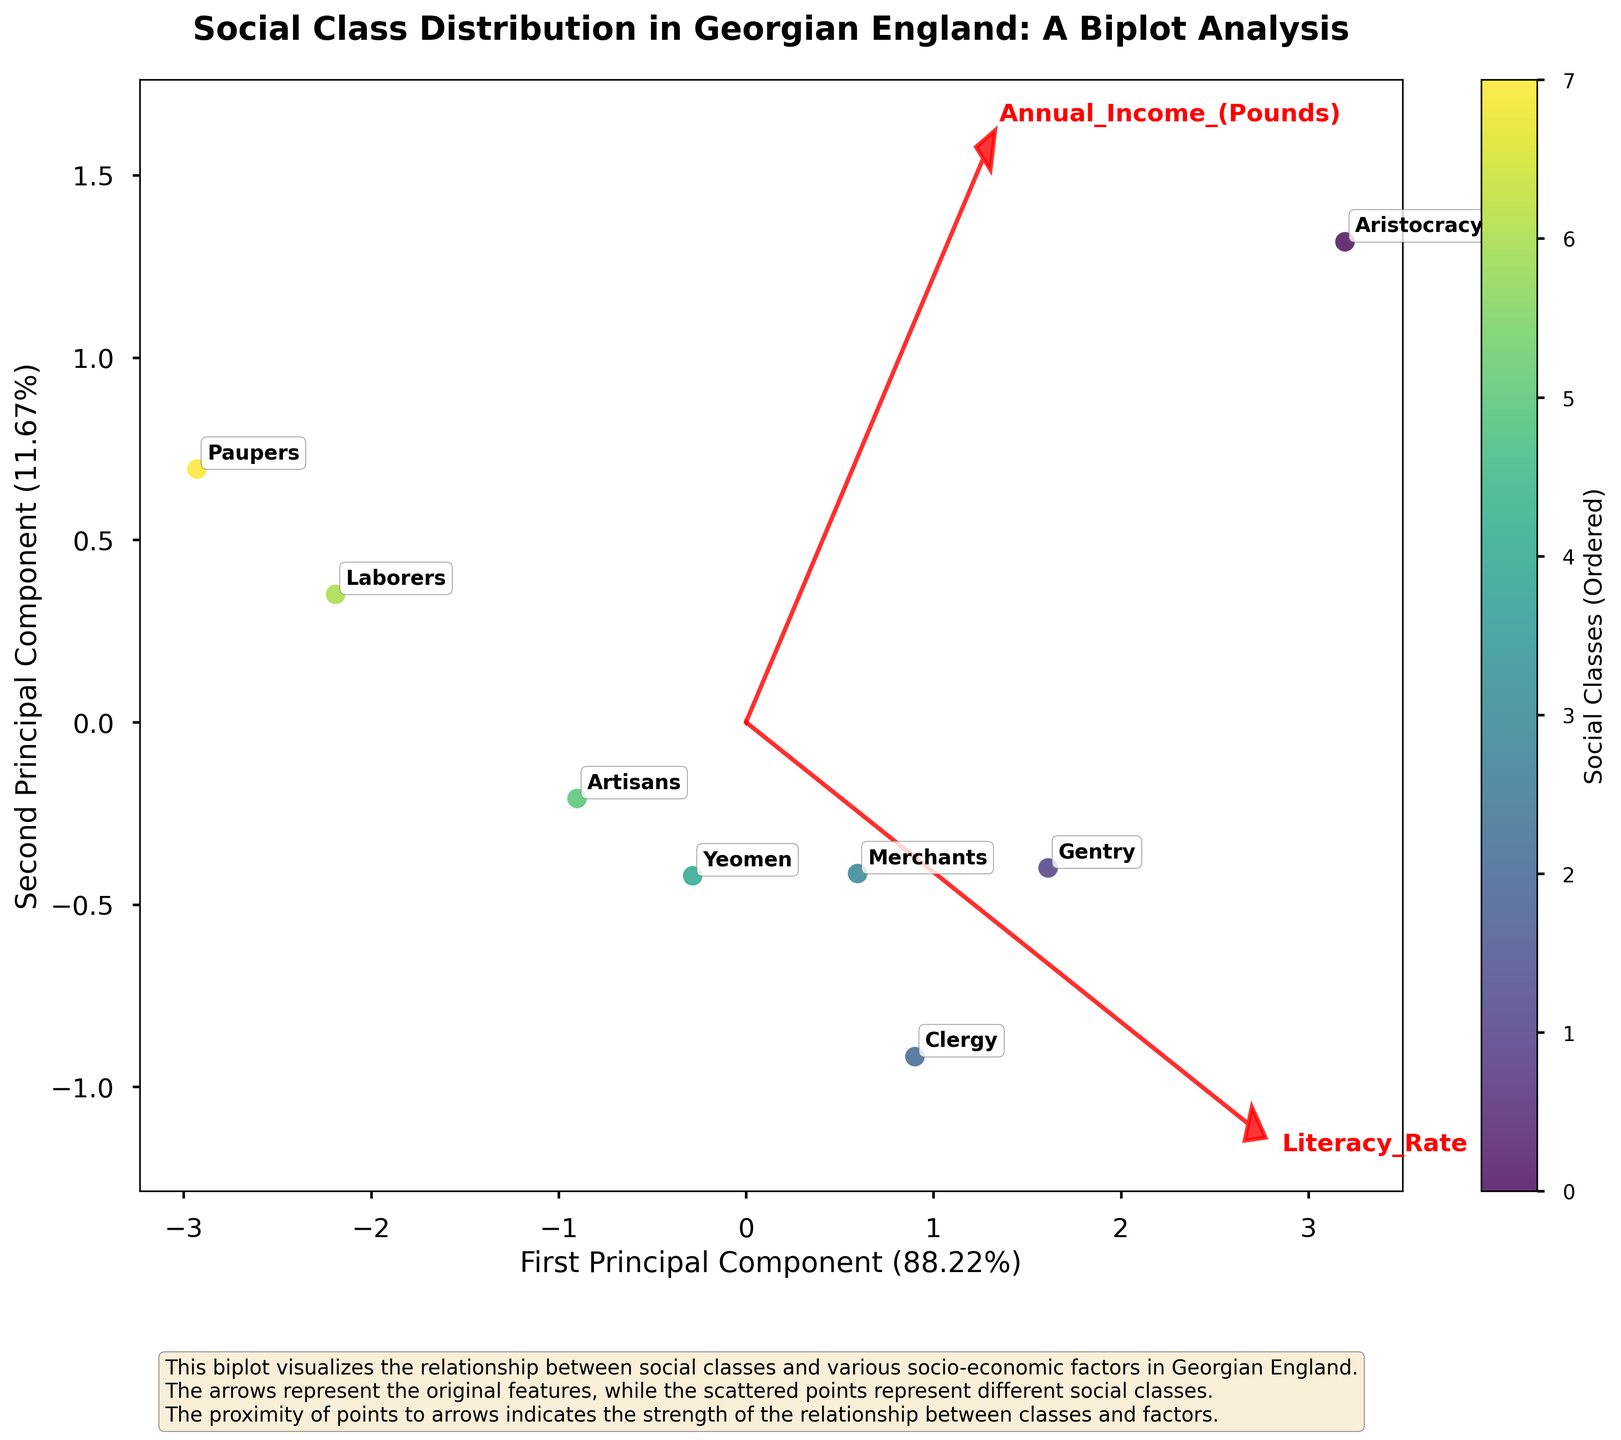What is the title of the biplot? The title is located at the top of the figure. It summarizes the content and context of the plot. The title reads "Social Class Distribution in Georgian England: A Biplot Analysis"
Answer: Social Class Distribution in Georgian England: A Biplot Analysis Which social class has the highest political influence? Political influence is one of the features represented by an arrow. The class point nearest to the "Political_Influence" arrow would have the highest value. The point identified as "Aristocracy" is closest to this arrow.
Answer: Aristocracy How do the life expectancy and literacy rate vectors relate to each other in the biplot? In the biplot, vectors that are in the same direction or close to each other indicate a positive correlation. The "Life_Expectancy" and "Literacy_Rate" vectors are pointed in similar directions, indicating a positive correlation between these two features.
Answer: Positive correlation Which social class is the furthest from the origin in the biplot? The distance from the origin can be observed on the plot. The point farthest from the origin is likely to be the most distinct in terms of features. "Aristocracy" appears to be the furthest from the origin.
Answer: Aristocracy Is the "Yeomen" class closer to the "Literacy_Rate" or "Annual_Income_(Pounds)" vector? By examining the biplot, one can observe the relative distance of "Yeomen" to both vectors. "Yeomen" is closer to the "Annual_Income_(Pounds)" vector than the "Literacy_Rate" vector.
Answer: Annual_Income_(Pounds) What percentage of variance is explained by the first principal component? This information is typically shown on the x-axis label. It is written as "First Principal Component" followed by a percentage. The percentage is 64.2%.
Answer: 64.2% Rank the social classes from highest to lowest based on their positioning along the first principal component. Positions along the first principal component can be seen from left to right on the x-axis. Sorted from highest to lowest: Aristocracy, Gentry, Merchants, Clergy, Yeomen, Artisans, Laborers, Paupers.
Answer: Aristocracy, Gentry, Merchants, Clergy, Yeomen, Artisans, Laborers, Paupers Which social class has the lowest life expectancy according to the biplot? The "Life_Expectancy" vector can be used as a reference. The class point nearest to the opposite direction of this vector will have the lowest value. "Paupers" is closest to this opposite direction.
Answer: Paupers Are there any social classes that are shown clustered closely together? If yes, which ones? Clusters of points indicate social classes with similar features. "Artisans" and "Yeomen" are relatively close together, indicating similar socio-economic characteristics.
Answer: Artisans and Yeomen 